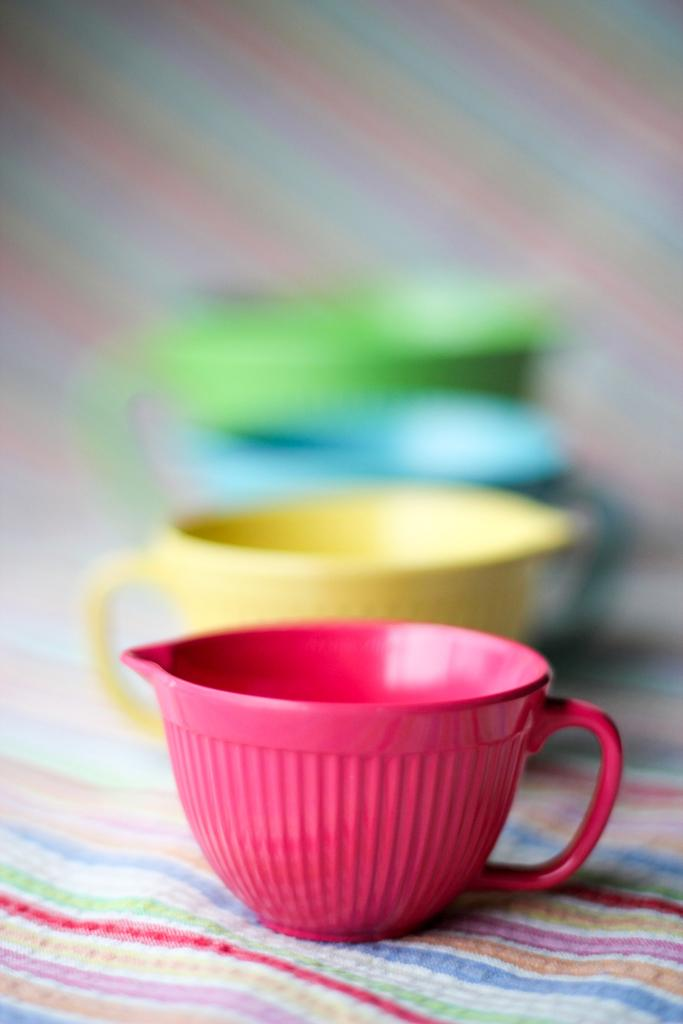What objects can be seen in the image? There are cups in the image. Can you describe the cups in more detail? The cups have different colors: pink, yellow, blue, and green. What is the cups placed on? The cups are on a cloth with multiple color stripes. What type of pain is the person experiencing in the image? There is no person present in the image, and therefore no indication of any pain. 